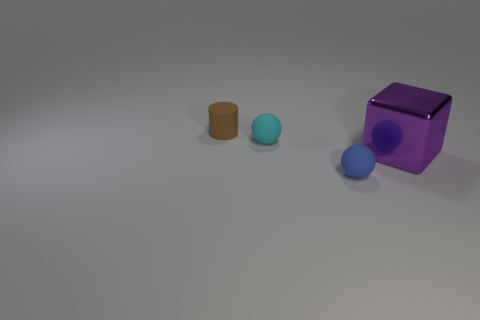Are there any other things that are the same size as the shiny thing?
Your answer should be very brief. No. How many other things are there of the same color as the cylinder?
Ensure brevity in your answer.  0. There is a brown matte thing that is left of the matte object that is on the right side of the cyan sphere; what is its shape?
Ensure brevity in your answer.  Cylinder. How many cyan rubber objects are in front of the purple shiny block?
Your response must be concise. 0. Are there any tiny cyan things made of the same material as the small brown cylinder?
Offer a very short reply. Yes. There is a cylinder that is the same size as the blue matte ball; what material is it?
Ensure brevity in your answer.  Rubber. What is the size of the thing that is both behind the blue sphere and in front of the cyan rubber object?
Give a very brief answer. Large. There is a object that is in front of the small cyan sphere and left of the large metallic object; what is its color?
Provide a succinct answer. Blue. Are there fewer shiny objects in front of the cylinder than small things that are behind the big shiny cube?
Ensure brevity in your answer.  Yes. What number of small brown things are the same shape as the cyan object?
Make the answer very short. 0. 